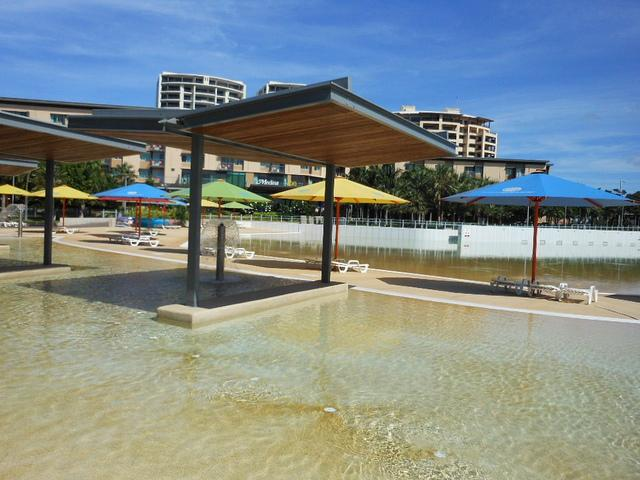This pool is mainly for what swimmers? Please explain your reasoning. kids. This small pool is mostly for little children. 